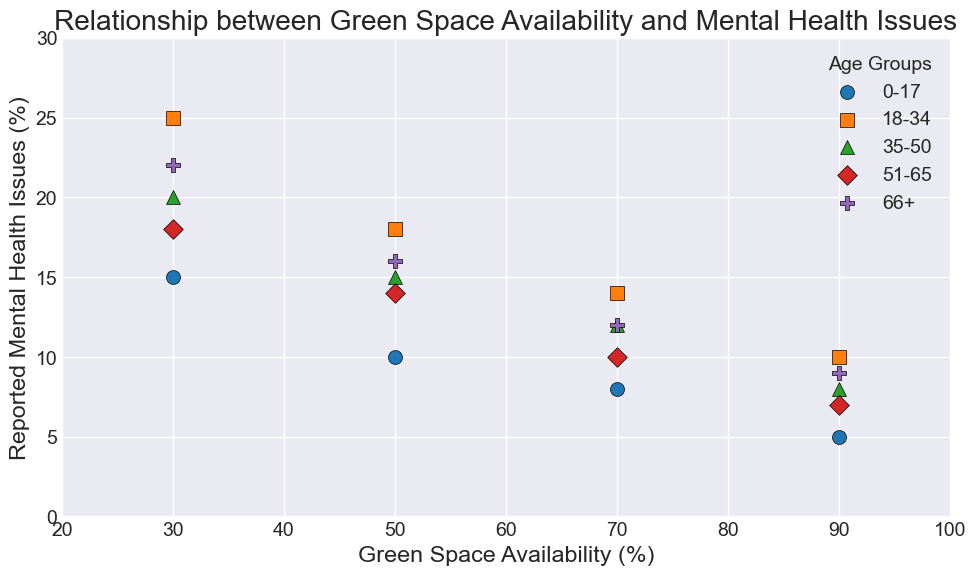Which age group shows the largest decrease in mental health issues as green space availability increases from 30% to 90%? Look at the data points for each age group at 30% and 90% green space availability. Subtract the mental health issues at 90% from those at 30% for each group. The differences are: 0-17: 10 (15-5), 18-34: 15 (25-10), 35-50: 12 (20-8), 51-65: 11 (18-7), 66+: 13 (22-9). The largest difference is for the 18-34 age group.
Answer: 18-34 Which age group has the highest percentage of mental health issues when green space availability is 30%? Identify the data points for each age group at 30% green space availability. The mental health percentages are: 0-17: 15%, 18-34: 25%, 35-50: 20%, 51-65: 18%, 66+: 22%. The highest percentage is for the 18-34 age group.
Answer: 18-34 What is the average number of reported mental health issues for the 66+ age group across all levels of green space availability? To calculate the average, add all the mental health issue percentages for the 66+ age group (30%, 22), (50%, 16), (70%, 12), (90%, 9), and divide by the number of data points. The sum is 22 + 16 + 12 + 9 = 59. Dividing by 4 gives an average of 59/4 = 14.75.
Answer: 14.75 Which age group shows the most significant improvement in mental health issues between 50% and 70% green space availability? Calculate the difference in reported mental health issues between 50% and 70% green space availability for each age group. The differences are: 0-17: 2 (10-8), 18-34: 4 (18-14), 35-50: 3 (15-12), 51-65: 4 (14-10), 66+: 4 (16-12). Multiple age groups show a 4-point improvement, so they exhibit the same significant improvement.
Answer: 18-34, 51-65, 66+ What trend do we observe between age groups and the reported mental health issues as green space availability increases? By analyzing the scatter plot for all age groups, we see that as green space availability increases from 30% to 90%, reported mental health issues decrease consistently across all age groups. This indicates a negative correlation between green space availability and reported mental health issues.
Answer: Decrease in mental health issues What is the total decrease in reported mental health issues for the 51-65 age group from 30% to 90% green space availability? Identify the mental health issues for the 51-65 age group at 30% and 90%. Subtract the value at 90% (7) from the value at 30% (18). The total decrease is 18 - 7 = 11.
Answer: 11 Which age group has the least reported mental health issues at 70% green space availability? Identify the mental health issues for each age group at 70% green space availability. The values are: 0-17: 8, 18-34: 14, 35-50: 12, 51-65: 10, 66+: 12. The least reported mental health issues are for the 0-17 age group.
Answer: 0-17 For the age group 35-50, what is the difference in reported mental health issues between 50% and 90% green space availability? Identify the reported mental health issues for the 35-50 age group at 50% (15) and 90% (8). Subtract the value at 90% from the value at 50%. The difference is 15 - 8 = 7.
Answer: 7 Is the relationship between green space availability and mental health issues visually different for different age groups? By visually examining the scatter plot, we note that all age groups show a decreasing trend in mental health issues as green space availability increases. However, the rate of decrease and the starting points (at 30%) differ among age groups, indicating slight variations in how each group responds to green space availability.
Answer: Yes 